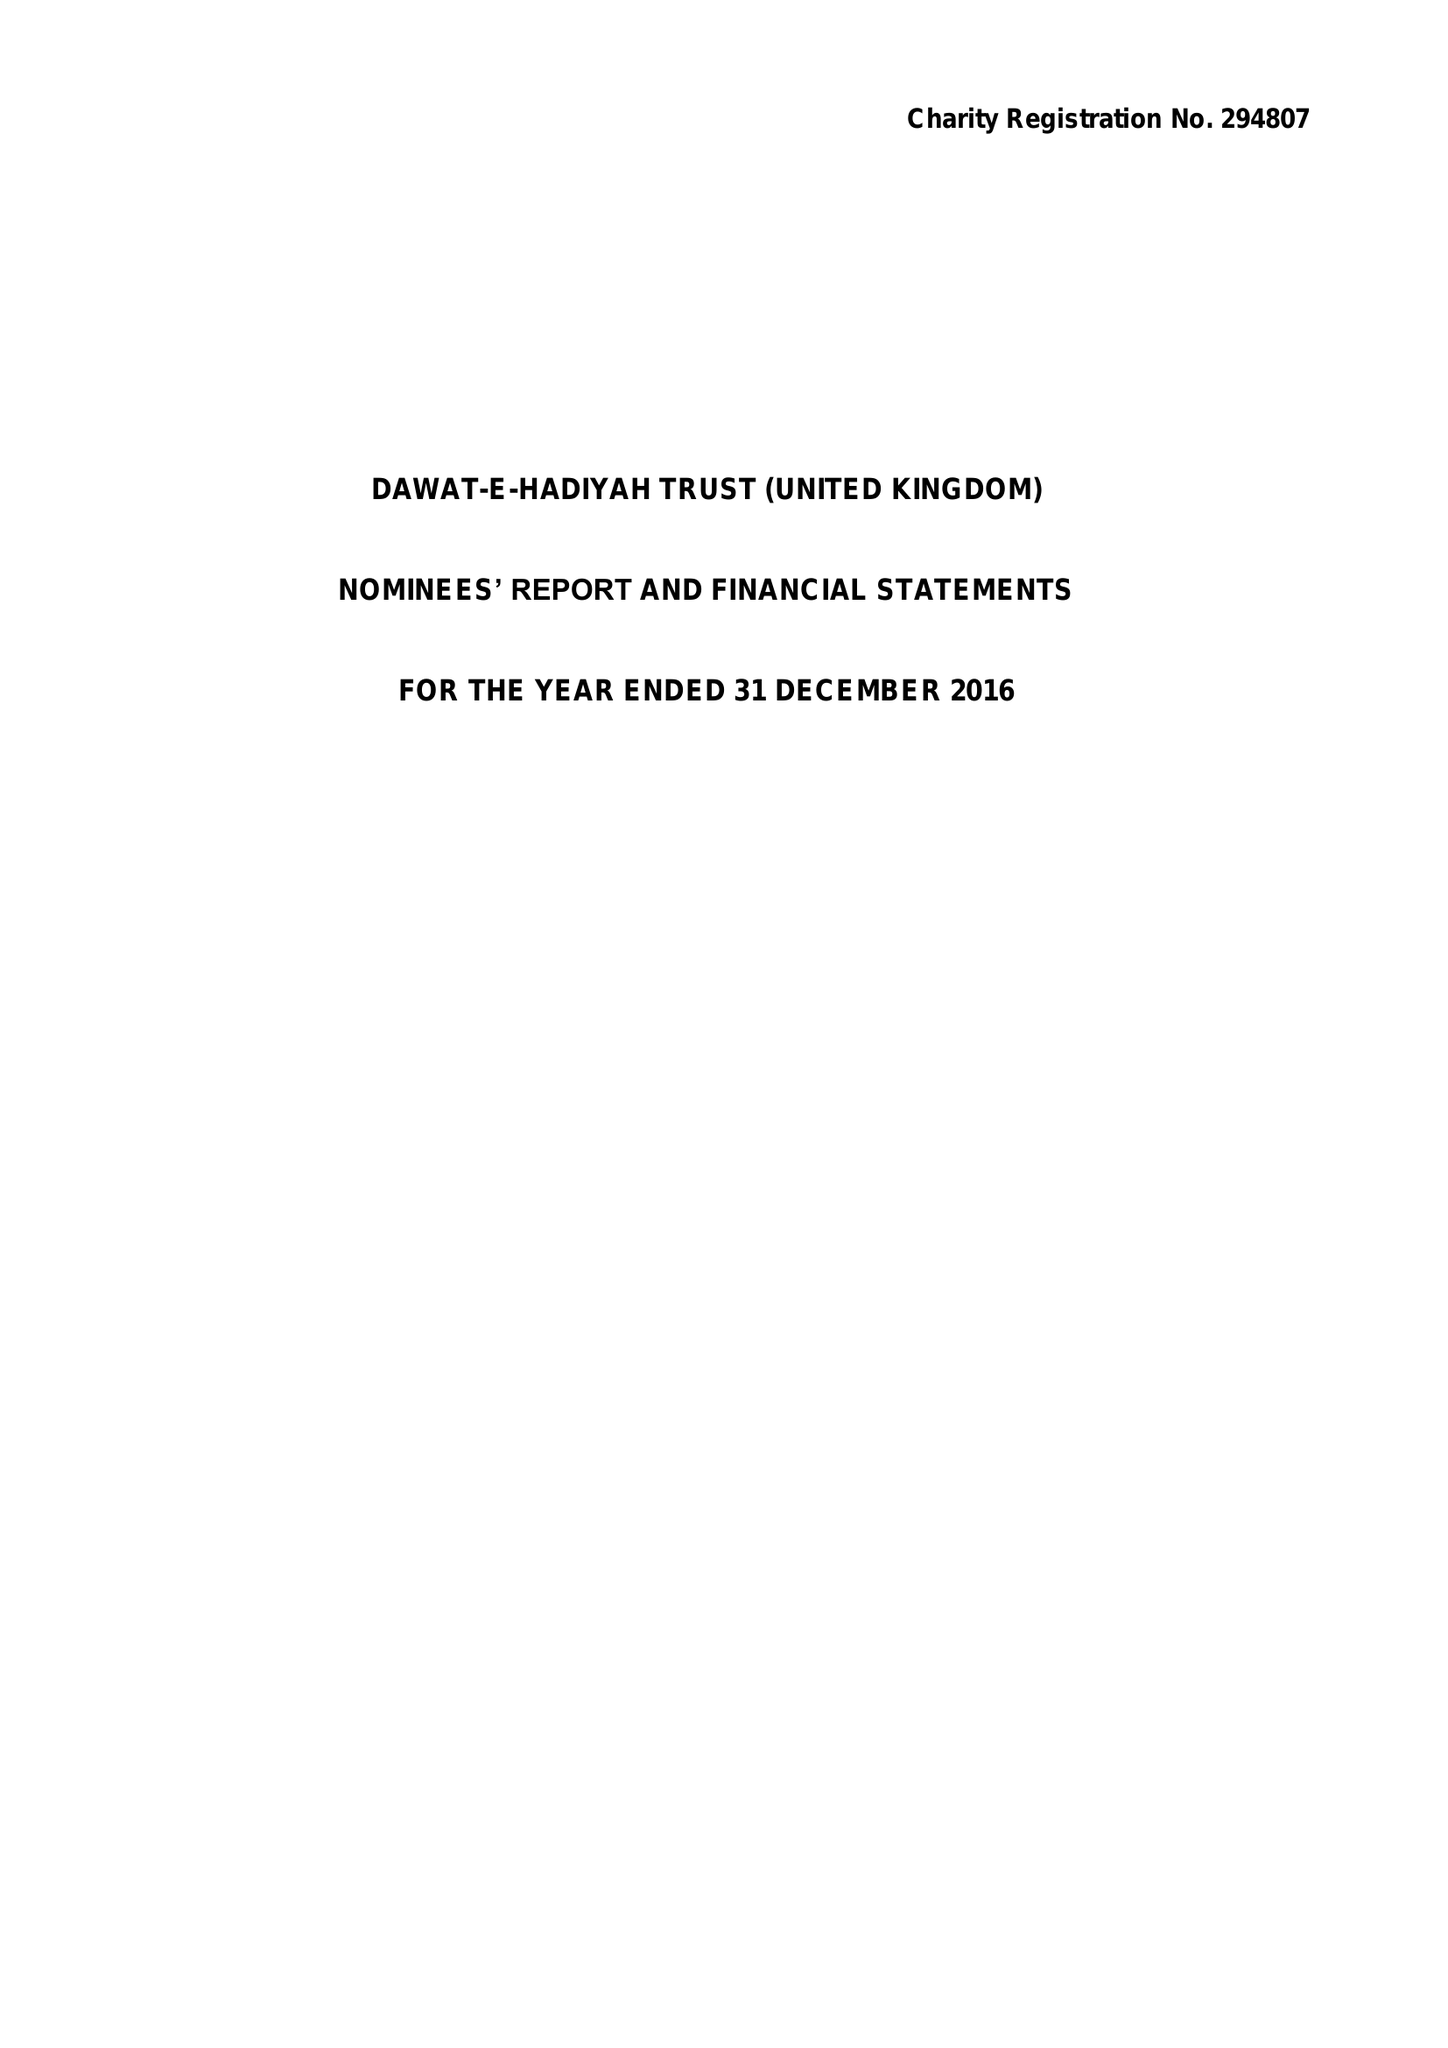What is the value for the report_date?
Answer the question using a single word or phrase. 2016-12-31 